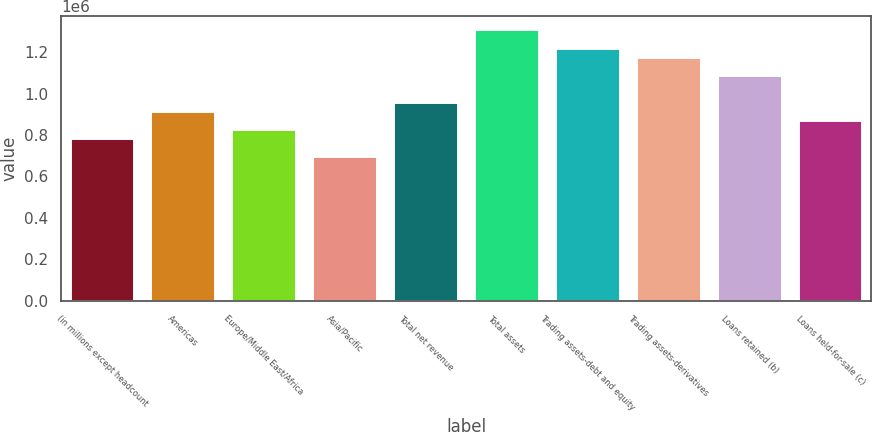Convert chart to OTSL. <chart><loc_0><loc_0><loc_500><loc_500><bar_chart><fcel>(in millions except headcount<fcel>Americas<fcel>Europe/Middle East/Africa<fcel>Asia/Pacific<fcel>Total net revenue<fcel>Total assets<fcel>Trading assets-debt and equity<fcel>Trading assets-derivatives<fcel>Loans retained (b)<fcel>Loans held-for-sale (c)<nl><fcel>785677<fcel>916623<fcel>829326<fcel>698380<fcel>960272<fcel>1.30946e+06<fcel>1.22216e+06<fcel>1.17851e+06<fcel>1.09122e+06<fcel>872974<nl></chart> 